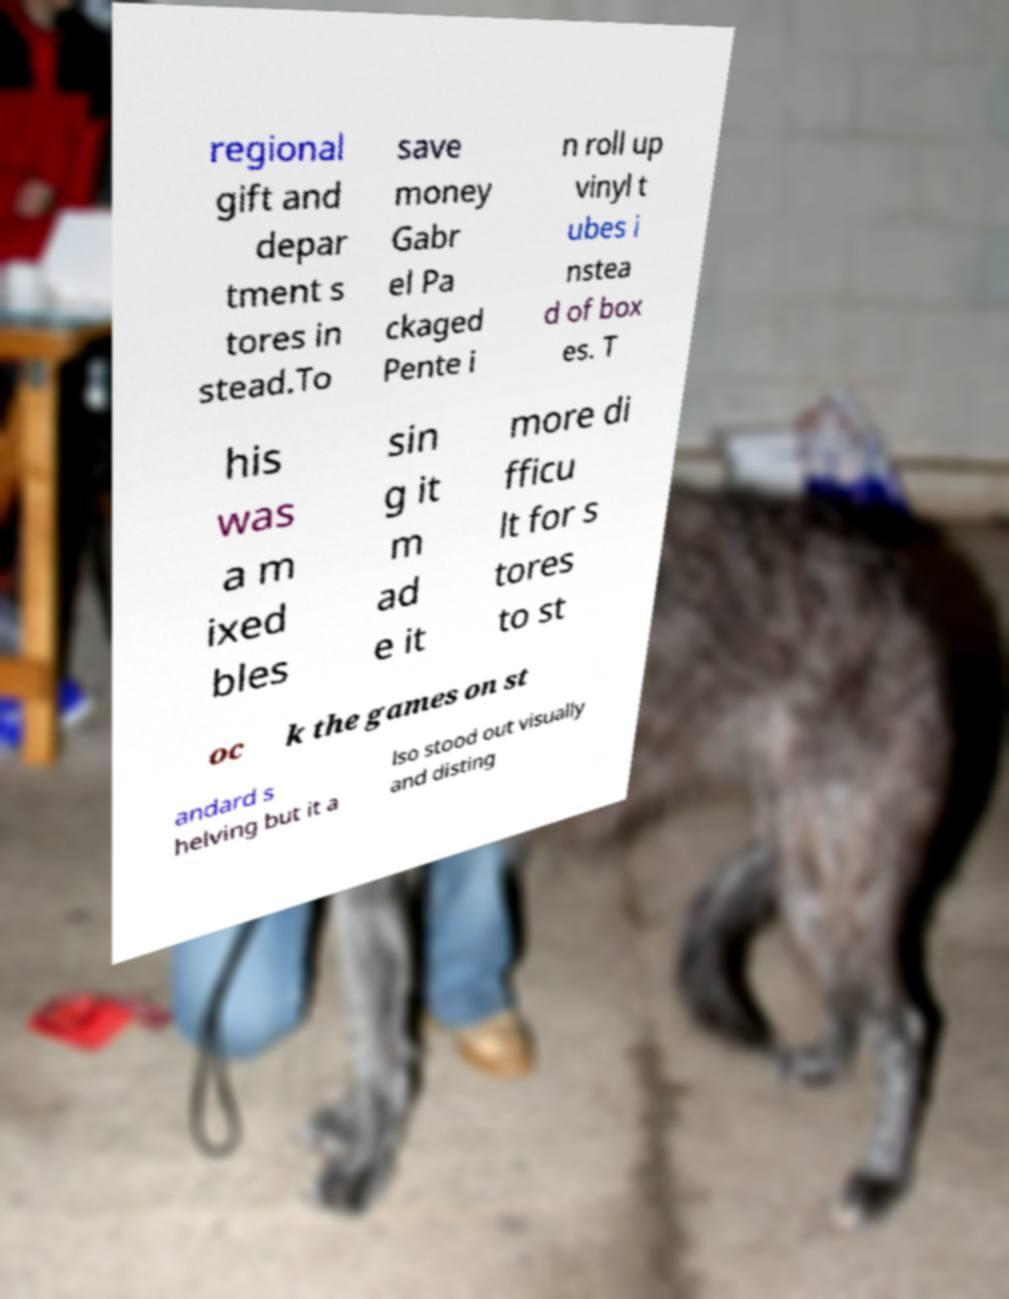What messages or text are displayed in this image? I need them in a readable, typed format. regional gift and depar tment s tores in stead.To save money Gabr el Pa ckaged Pente i n roll up vinyl t ubes i nstea d of box es. T his was a m ixed bles sin g it m ad e it more di fficu lt for s tores to st oc k the games on st andard s helving but it a lso stood out visually and disting 